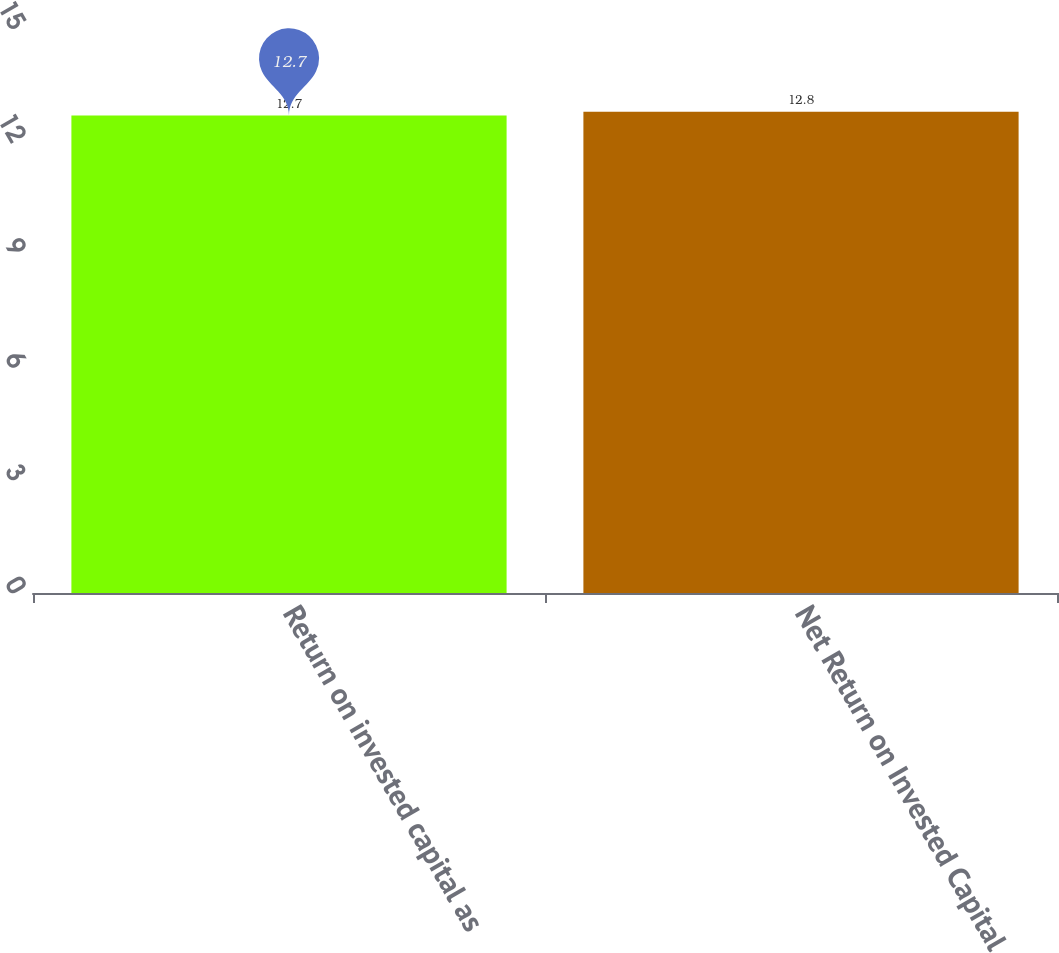Convert chart. <chart><loc_0><loc_0><loc_500><loc_500><bar_chart><fcel>Return on invested capital as<fcel>Net Return on Invested Capital<nl><fcel>12.7<fcel>12.8<nl></chart> 